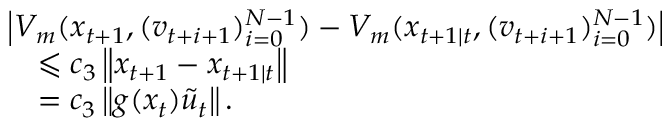<formula> <loc_0><loc_0><loc_500><loc_500>\begin{array} { r l } & { \left | V _ { m } ( x _ { t + 1 } , ( v _ { t + i + 1 } ) _ { i = 0 } ^ { N - 1 } ) - V _ { m } ( x _ { t + 1 | t } , ( v _ { t + i + 1 } ) _ { i = 0 } ^ { N - 1 } ) \right | } \\ & { \quad \leqslant c _ { 3 } \left \| x _ { t + 1 } - x _ { t + 1 | t } \right \| } \\ & { \quad = c _ { 3 } \left \| g ( x _ { t } ) \tilde { u } _ { t } \right \| . } \end{array}</formula> 